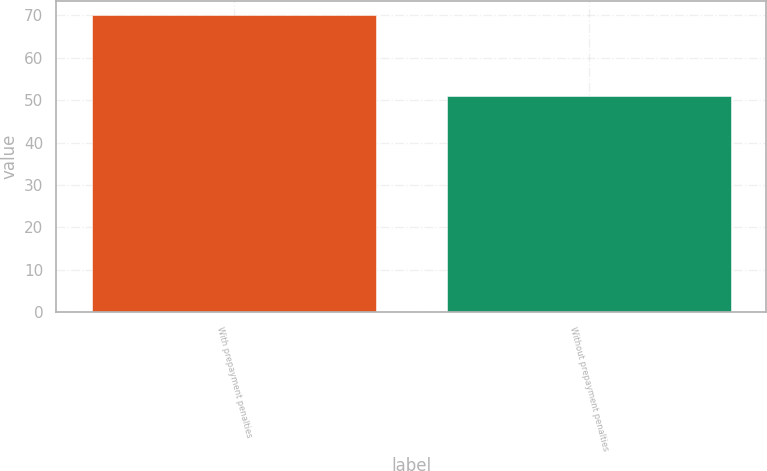Convert chart to OTSL. <chart><loc_0><loc_0><loc_500><loc_500><bar_chart><fcel>With prepayment penalties<fcel>Without prepayment penalties<nl><fcel>70<fcel>51<nl></chart> 